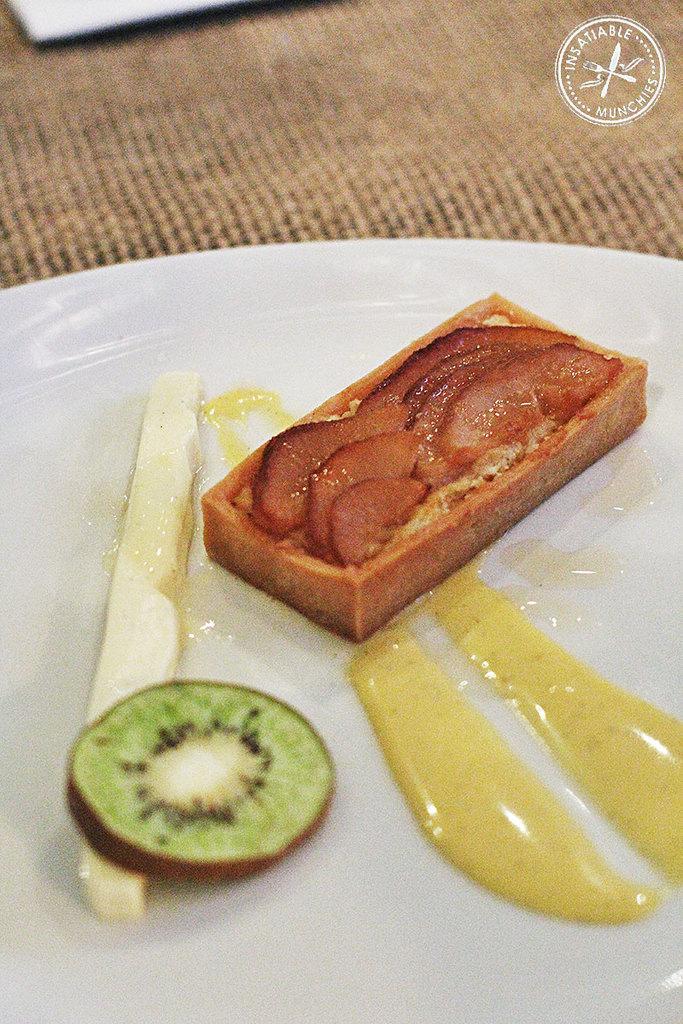Please provide a concise description of this image. There are food items on a white color plate. On the top right, there is a watermark. In the background, there is an object on a cloth. 